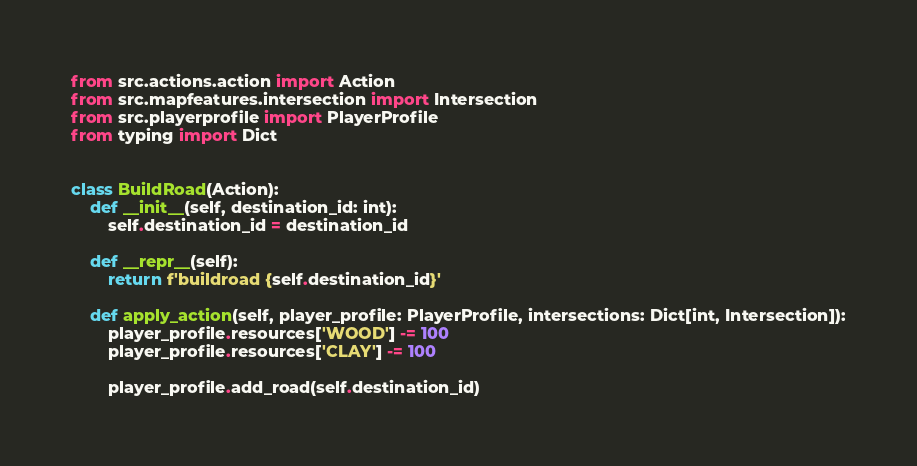<code> <loc_0><loc_0><loc_500><loc_500><_Python_>from src.actions.action import Action
from src.mapfeatures.intersection import Intersection
from src.playerprofile import PlayerProfile
from typing import Dict


class BuildRoad(Action):
    def __init__(self, destination_id: int):
        self.destination_id = destination_id

    def __repr__(self):
        return f'buildroad {self.destination_id}'

    def apply_action(self, player_profile: PlayerProfile, intersections: Dict[int, Intersection]):
        player_profile.resources['WOOD'] -= 100
        player_profile.resources['CLAY'] -= 100

        player_profile.add_road(self.destination_id)

</code> 